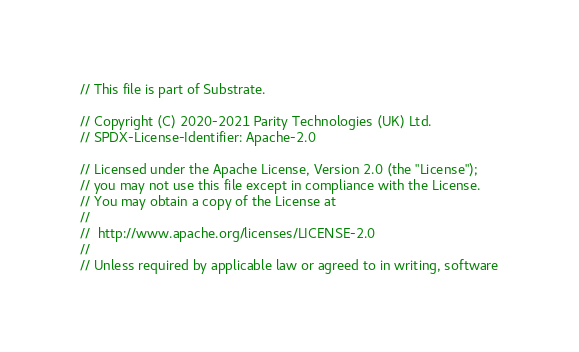<code> <loc_0><loc_0><loc_500><loc_500><_Rust_>// This file is part of Substrate.

// Copyright (C) 2020-2021 Parity Technologies (UK) Ltd.
// SPDX-License-Identifier: Apache-2.0

// Licensed under the Apache License, Version 2.0 (the "License");
// you may not use this file except in compliance with the License.
// You may obtain a copy of the License at
//
// 	http://www.apache.org/licenses/LICENSE-2.0
//
// Unless required by applicable law or agreed to in writing, software</code> 